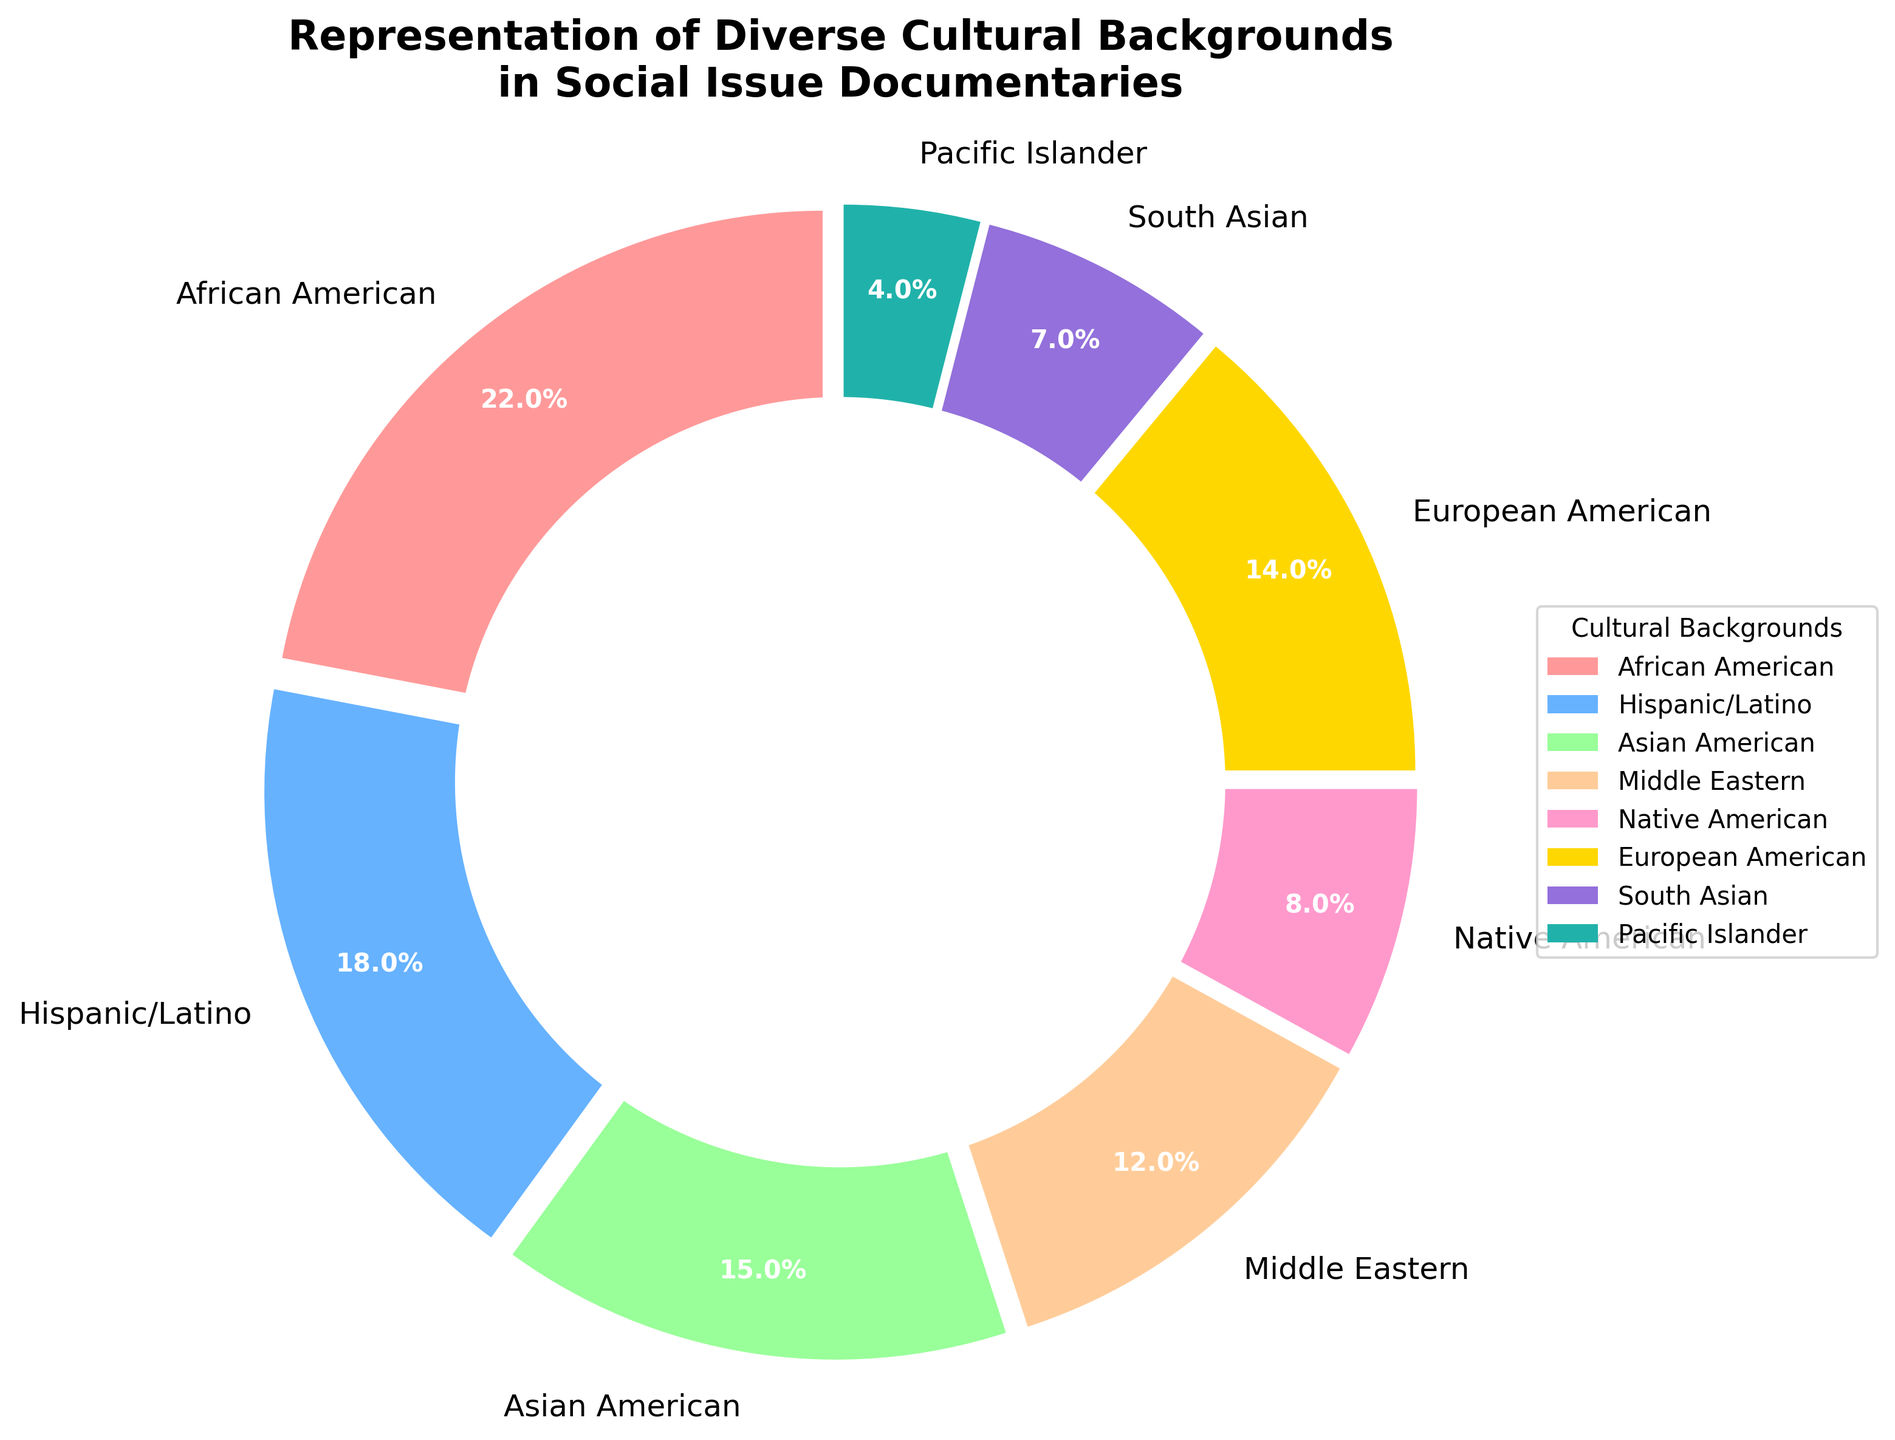What's the combined percentage of African American and Hispanic/Latino representation? African American representation is 22% and Hispanic/Latino is 18%. Adding the two percentages gives 22% + 18% = 40%
Answer: 40% Which cultural background has the smallest representation? From the pie chart, Pacific Islander has a representation of 4%, which is the smallest percentage among all the categories.
Answer: Pacific Islander Are Asian American or Middle Eastern represented more in the documentaries, and by how much? Asian American representation is 15% and Middle Eastern is 12%. The difference is 15% - 12% = 3%, with Asian American having a higher representation.
Answer: Asian American by 3% Which cultural background is represented more—Native American or South Asian? Native American has a representation of 8% whereas South Asian has 7%. Comparing these percentages, Native American has a higher representation.
Answer: Native American What is the sum of the percentages of the three least represented cultural backgrounds? The least represented cultural backgrounds are Pacific Islander (4%), South Asian (7%), and Native American (8%). Summing these gives 4% + 7% + 8% = 19%
Answer: 19% What's the difference in representation between the highest and the lowest cultural background categories? The highest representation is African American (22%) and the lowest is Pacific Islander (4%). The difference is 22% - 4% = 18%
Answer: 18% What percentage of the cultural backgrounds have more than 15% representation? The cultural backgrounds with more than 15% representation are African American (22%) and Hispanic/Latino (18%). There are two categories.
Answer: Two 